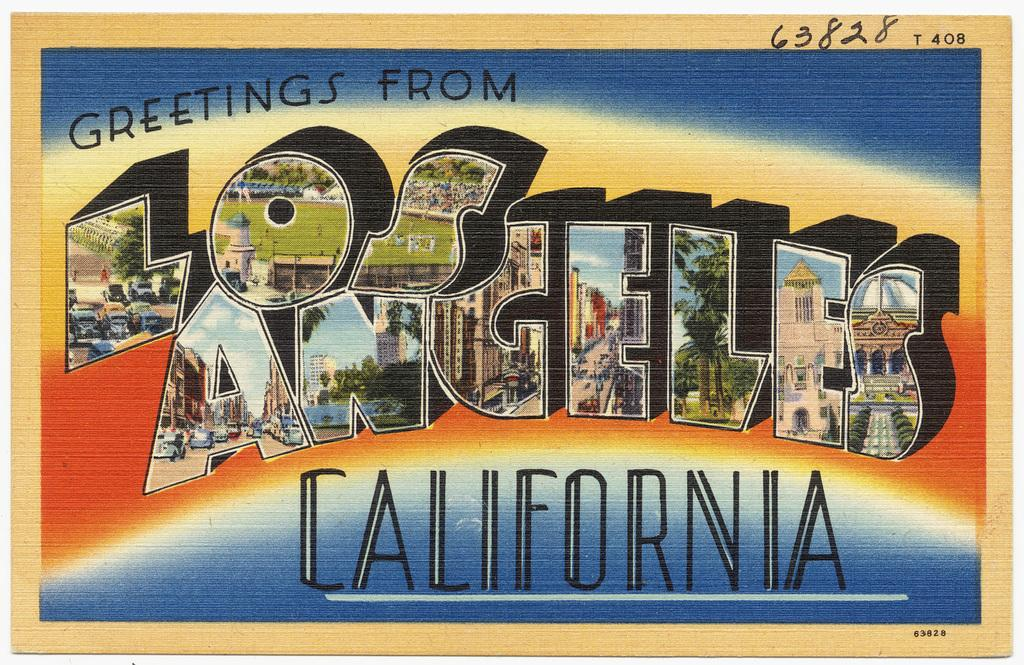<image>
Describe the image concisely. A post card from Los Angeles California containing pictures on each letter. 